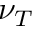Convert formula to latex. <formula><loc_0><loc_0><loc_500><loc_500>\nu _ { T }</formula> 